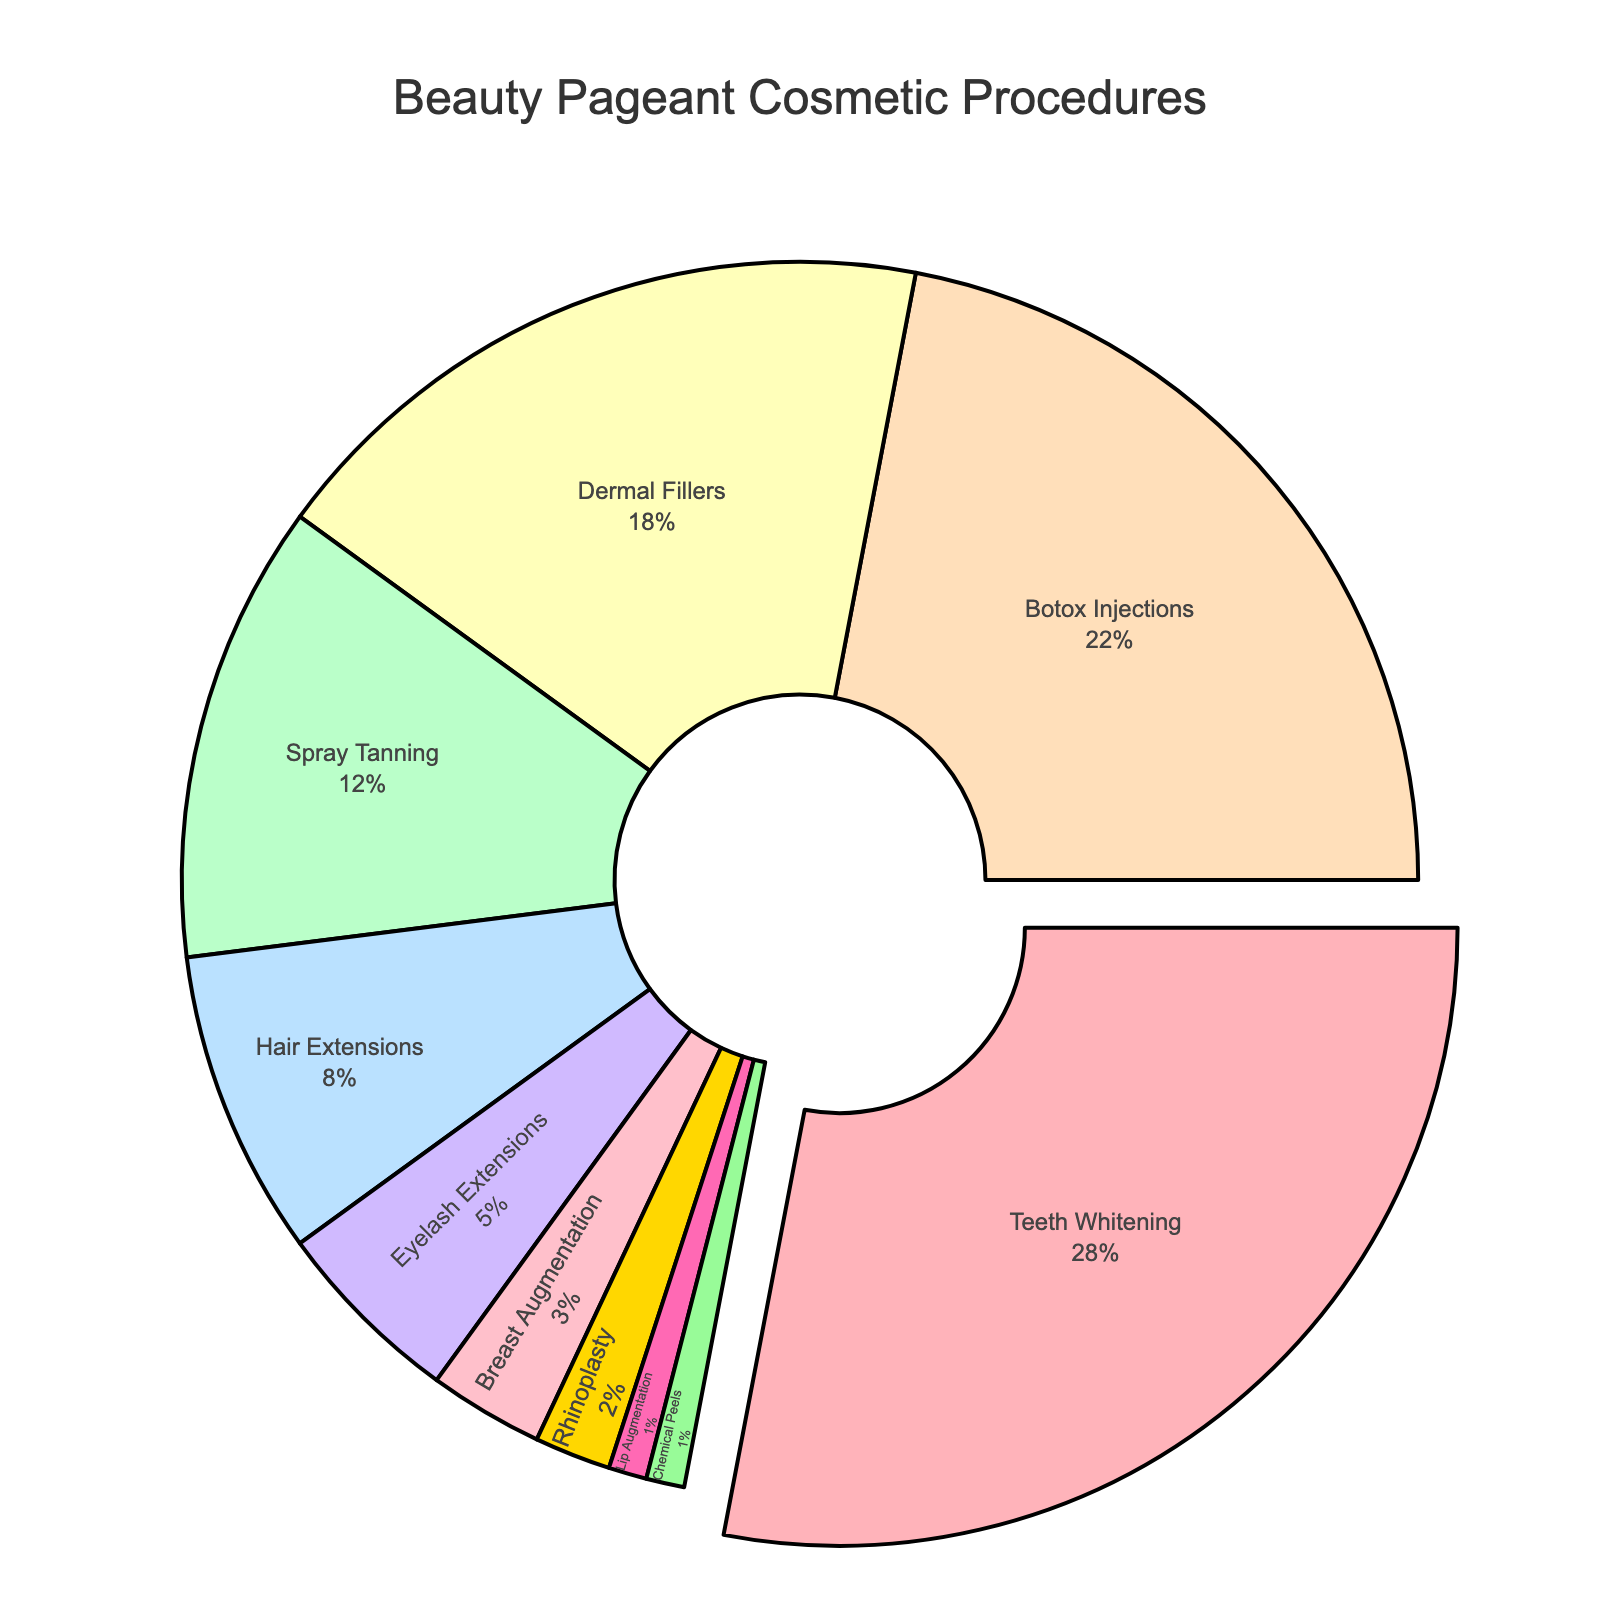What's the most popular cosmetic procedure chosen by beauty pageant contestants? According to the pie chart, the procedure with the largest slice is Teeth Whitening.
Answer: Teeth Whitening Which procedure accounts for the smallest percentage of choices? The chart indicates that both Lip Augmentation and Chemical Peels have the smallest slices, each representing 1%.
Answer: Lip Augmentation, Chemical Peels How much more popular is Botox Injections compared to Spray Tanning? The pie chart shows Botox Injections at 22% and Spray Tanning at 12%. The difference is 22% - 12% = 10%.
Answer: 10% Rank the top three procedures based on their popularity. The chart's largest slices corresponding to the top procedures are Teeth Whitening (28%), followed by Botox Injections (22%), and then Dermal Fillers (18%).
Answer: Teeth Whitening, Botox Injections, Dermal Fillers Which color represents Hair Extensions, and where is it positioned in terms of popularity? Hair Extensions is represented by a light pinkish shade and is the fifth largest segment, accounting for 8% of the choices.
Answer: Light pinkish, fifth If a contestant favored Dermal Fillers, Botox Injections, and Teeth Whitening, what total percentage of popularity do these procedures have altogether? Summing the percentages from the chart: Dermal Fillers (18%) + Botox Injections (22%) + Teeth Whitening (28%) = 68%.
Answer: 68% How do Eyelash Extensions compare to Breast Augmentation in terms of percentage? Eyelash Extensions are at 5%, while Breast Augmentation stands at 3%. Therefore, Eyelash Extensions are more popular by 2%.
Answer: Eyelash Extensions are 2% more popular Which procedure had a visual highlight such as a "pull" effect on the pie chart? The procedure that had the "pull" effect highlighting it is Teeth Whitening, marking its prominence as it’s the largest segment.
Answer: Teeth Whitening What is the combined percentage of all procedures that are less than 5%? Adding the percentages for procedures less than 5%: Eyelash Extensions (5%), Breast Augmentation (3%), Rhinoplasty (2%), Lip Augmentation (1%), and Chemical Peels (1%) gives 5% + 3% + 2% + 1% + 1% = 12%.
Answer: 12% Does Spray Tanning have more or less than double the percentage of Hair Extensions? Spray Tanning is at 12% and Hair Extensions are at 8%. Double of Hair Extensions is 16%, so Spray Tanning has less than double the percentage of Hair Extensions.
Answer: Less 